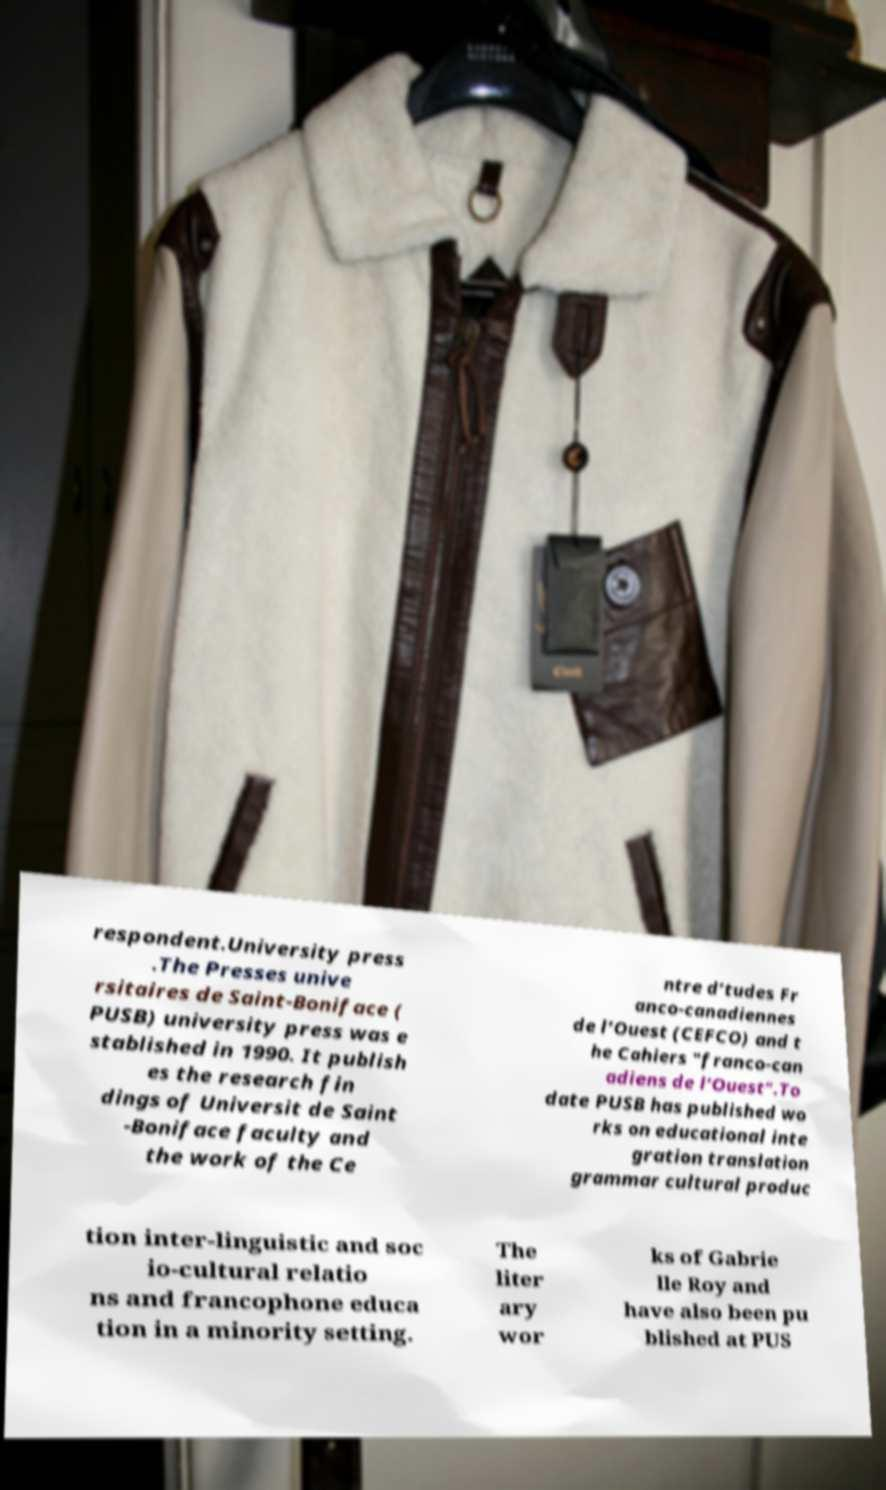For documentation purposes, I need the text within this image transcribed. Could you provide that? respondent.University press .The Presses unive rsitaires de Saint-Boniface ( PUSB) university press was e stablished in 1990. It publish es the research fin dings of Universit de Saint -Boniface faculty and the work of the Ce ntre d’tudes Fr anco-canadiennes de l’Ouest (CEFCO) and t he Cahiers "franco-can adiens de l’Ouest".To date PUSB has published wo rks on educational inte gration translation grammar cultural produc tion inter-linguistic and soc io-cultural relatio ns and francophone educa tion in a minority setting. The liter ary wor ks of Gabrie lle Roy and have also been pu blished at PUS 